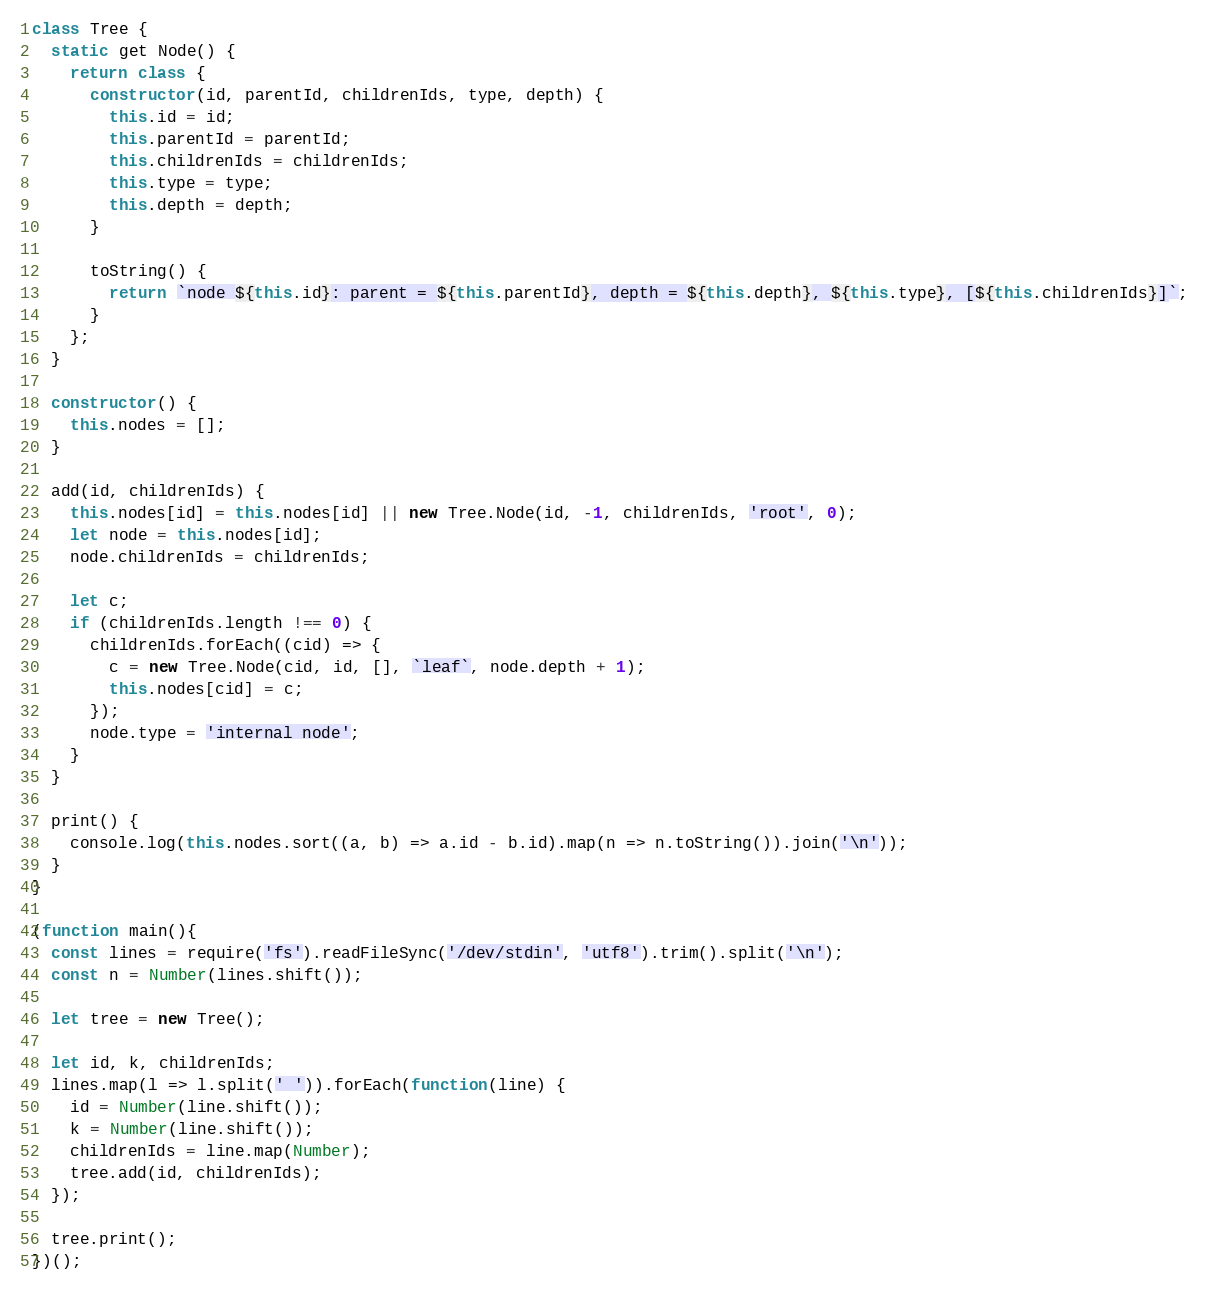Convert code to text. <code><loc_0><loc_0><loc_500><loc_500><_JavaScript_>class Tree {
  static get Node() {
    return class {
      constructor(id, parentId, childrenIds, type, depth) {
        this.id = id;
        this.parentId = parentId;
        this.childrenIds = childrenIds;
        this.type = type;
        this.depth = depth;
      }

      toString() {
        return `node ${this.id}: parent = ${this.parentId}, depth = ${this.depth}, ${this.type}, [${this.childrenIds}]`;
      }
    };
  }

  constructor() {
    this.nodes = [];
  }

  add(id, childrenIds) {
    this.nodes[id] = this.nodes[id] || new Tree.Node(id, -1, childrenIds, 'root', 0);
    let node = this.nodes[id];
    node.childrenIds = childrenIds;

    let c;
    if (childrenIds.length !== 0) {
      childrenIds.forEach((cid) => {
        c = new Tree.Node(cid, id, [], `leaf`, node.depth + 1);
        this.nodes[cid] = c;
      });
      node.type = 'internal node';
    }
  }

  print() {
    console.log(this.nodes.sort((a, b) => a.id - b.id).map(n => n.toString()).join('\n'));
  }
}

(function main(){
  const lines = require('fs').readFileSync('/dev/stdin', 'utf8').trim().split('\n');
  const n = Number(lines.shift());

  let tree = new Tree();

  let id, k, childrenIds;
  lines.map(l => l.split(' ')).forEach(function(line) {
    id = Number(line.shift());
    k = Number(line.shift());
    childrenIds = line.map(Number);
    tree.add(id, childrenIds);
  });

  tree.print();
})();

</code> 